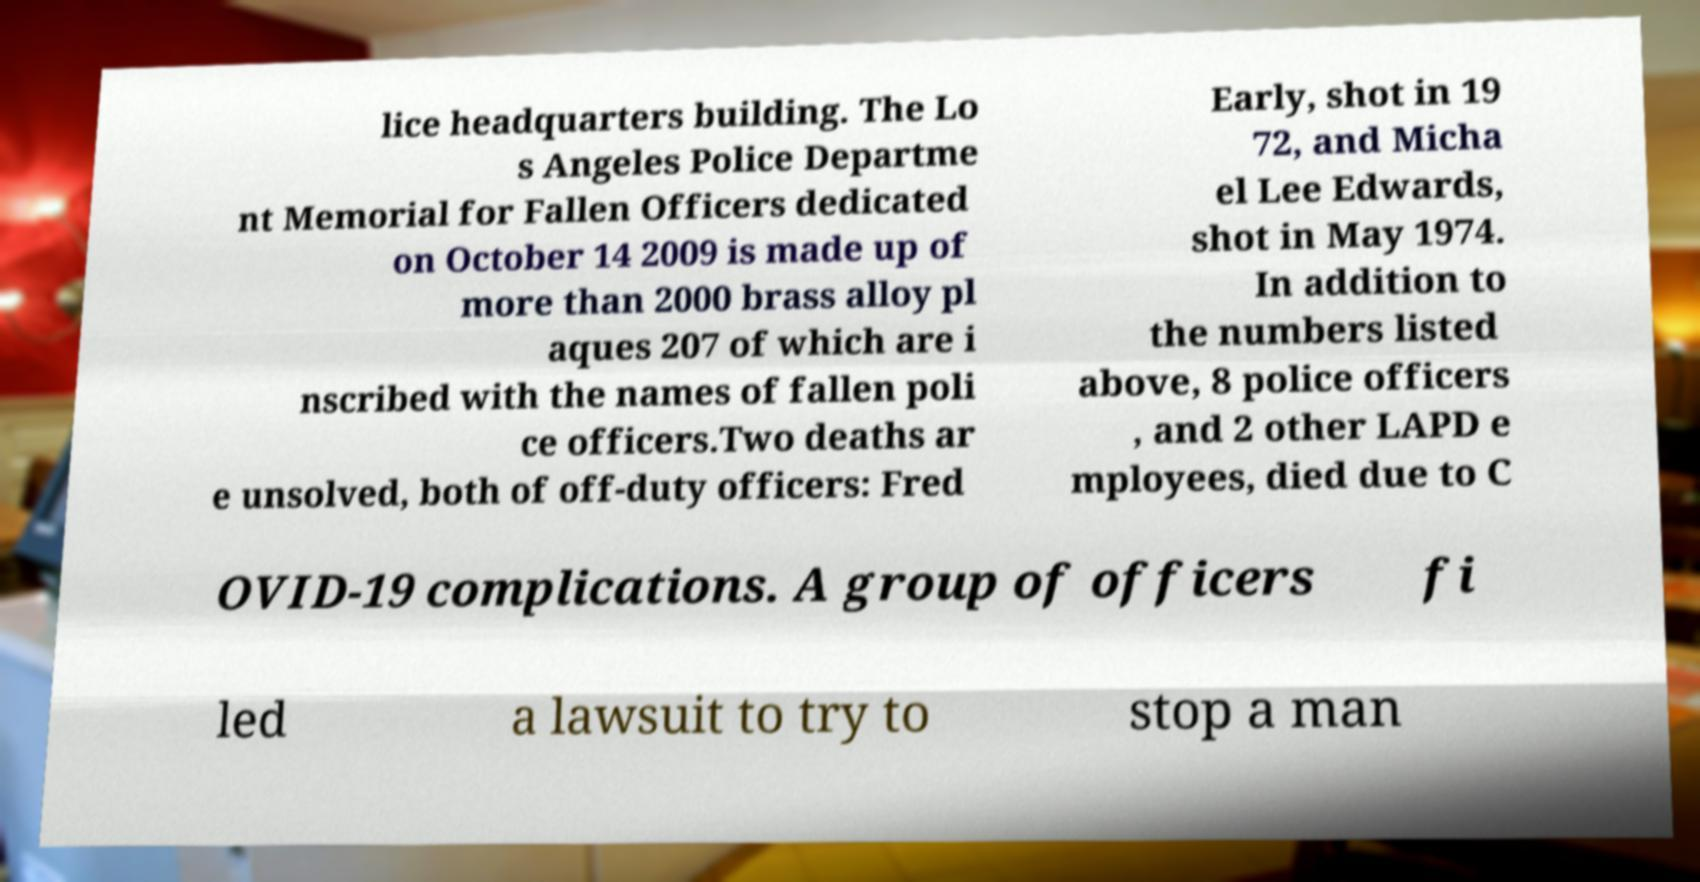I need the written content from this picture converted into text. Can you do that? lice headquarters building. The Lo s Angeles Police Departme nt Memorial for Fallen Officers dedicated on October 14 2009 is made up of more than 2000 brass alloy pl aques 207 of which are i nscribed with the names of fallen poli ce officers.Two deaths ar e unsolved, both of off-duty officers: Fred Early, shot in 19 72, and Micha el Lee Edwards, shot in May 1974. In addition to the numbers listed above, 8 police officers , and 2 other LAPD e mployees, died due to C OVID-19 complications. A group of officers fi led a lawsuit to try to stop a man 